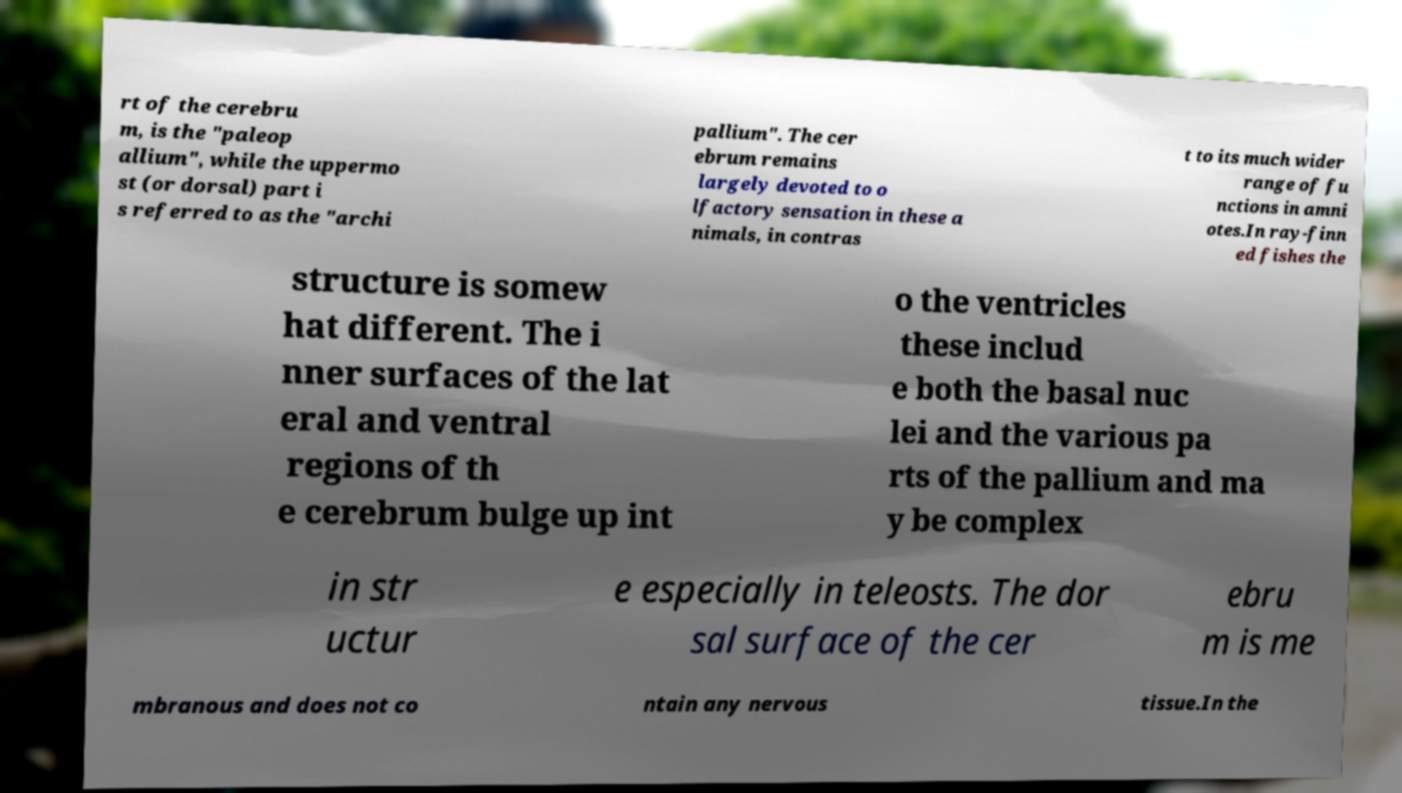Please read and relay the text visible in this image. What does it say? rt of the cerebru m, is the "paleop allium", while the uppermo st (or dorsal) part i s referred to as the "archi pallium". The cer ebrum remains largely devoted to o lfactory sensation in these a nimals, in contras t to its much wider range of fu nctions in amni otes.In ray-finn ed fishes the structure is somew hat different. The i nner surfaces of the lat eral and ventral regions of th e cerebrum bulge up int o the ventricles these includ e both the basal nuc lei and the various pa rts of the pallium and ma y be complex in str uctur e especially in teleosts. The dor sal surface of the cer ebru m is me mbranous and does not co ntain any nervous tissue.In the 